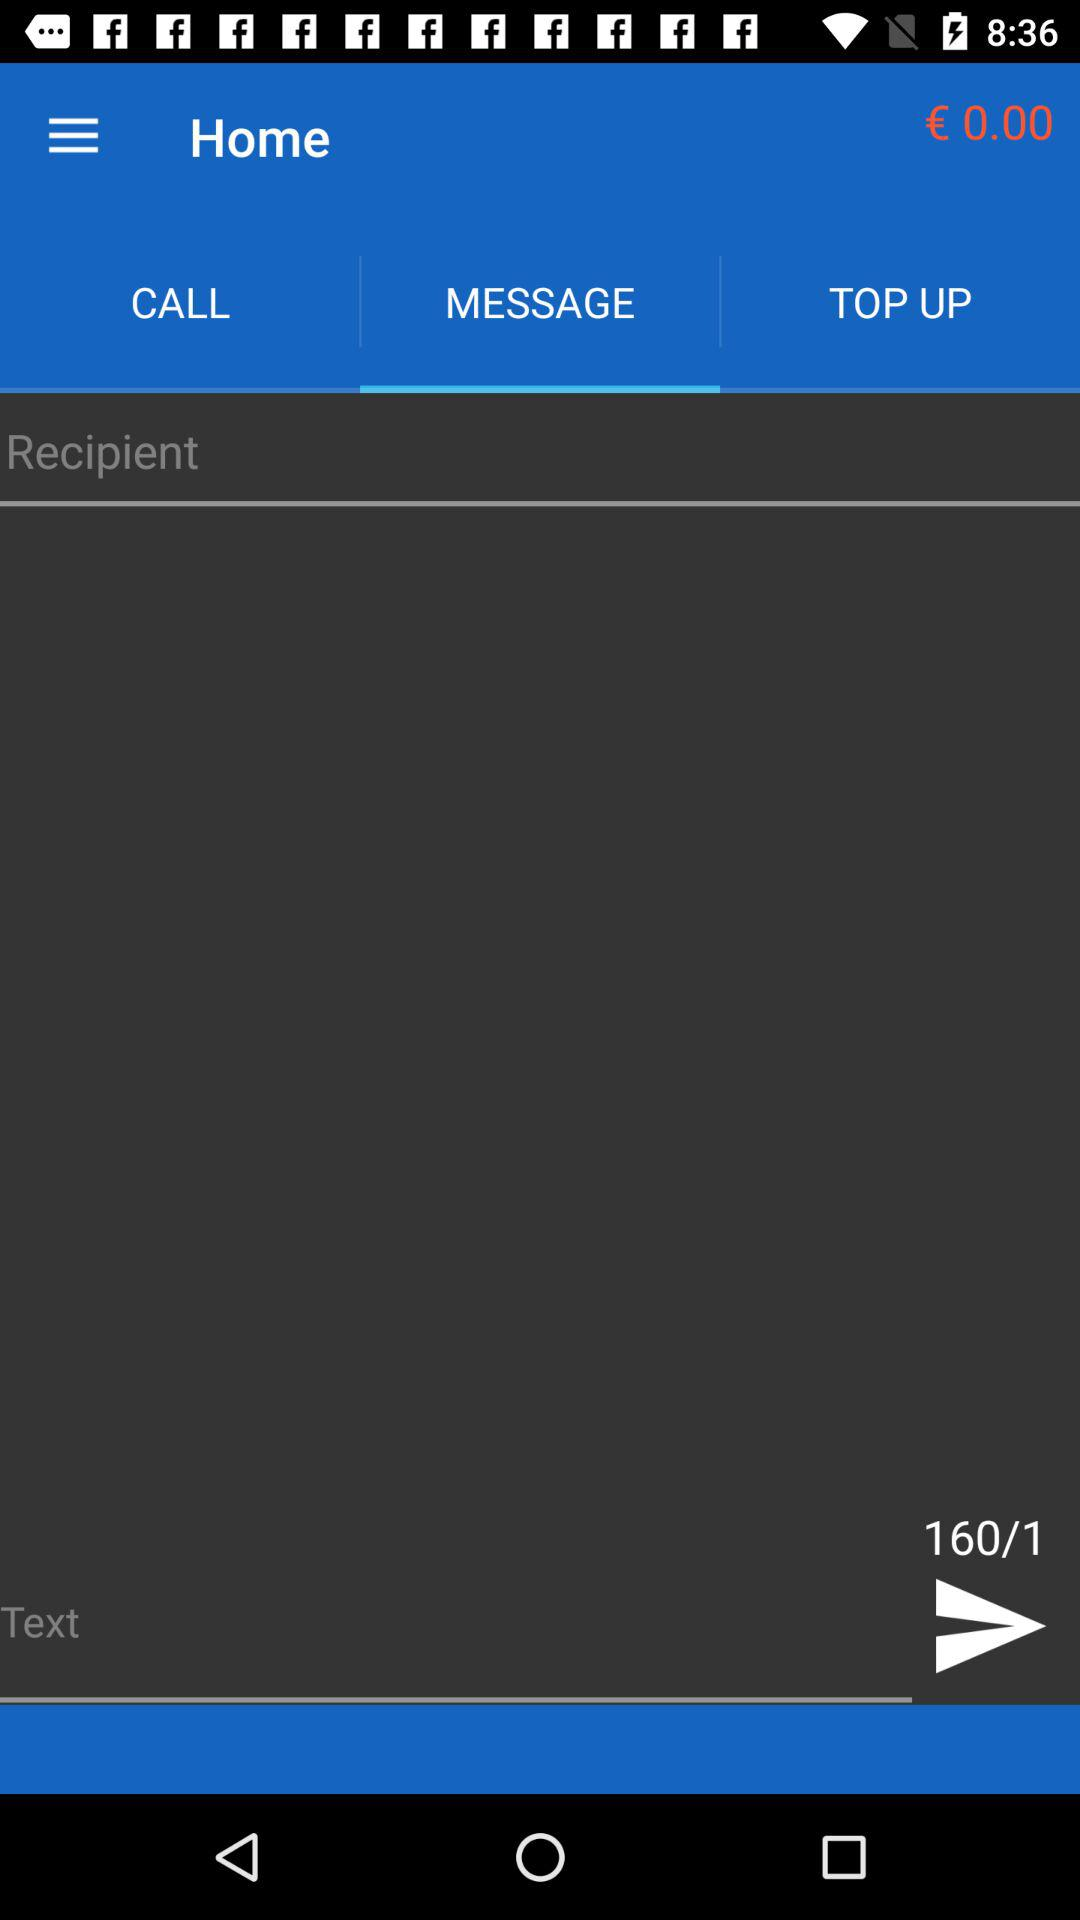What option is selected in the home bar? The option is "MESSAGE". 